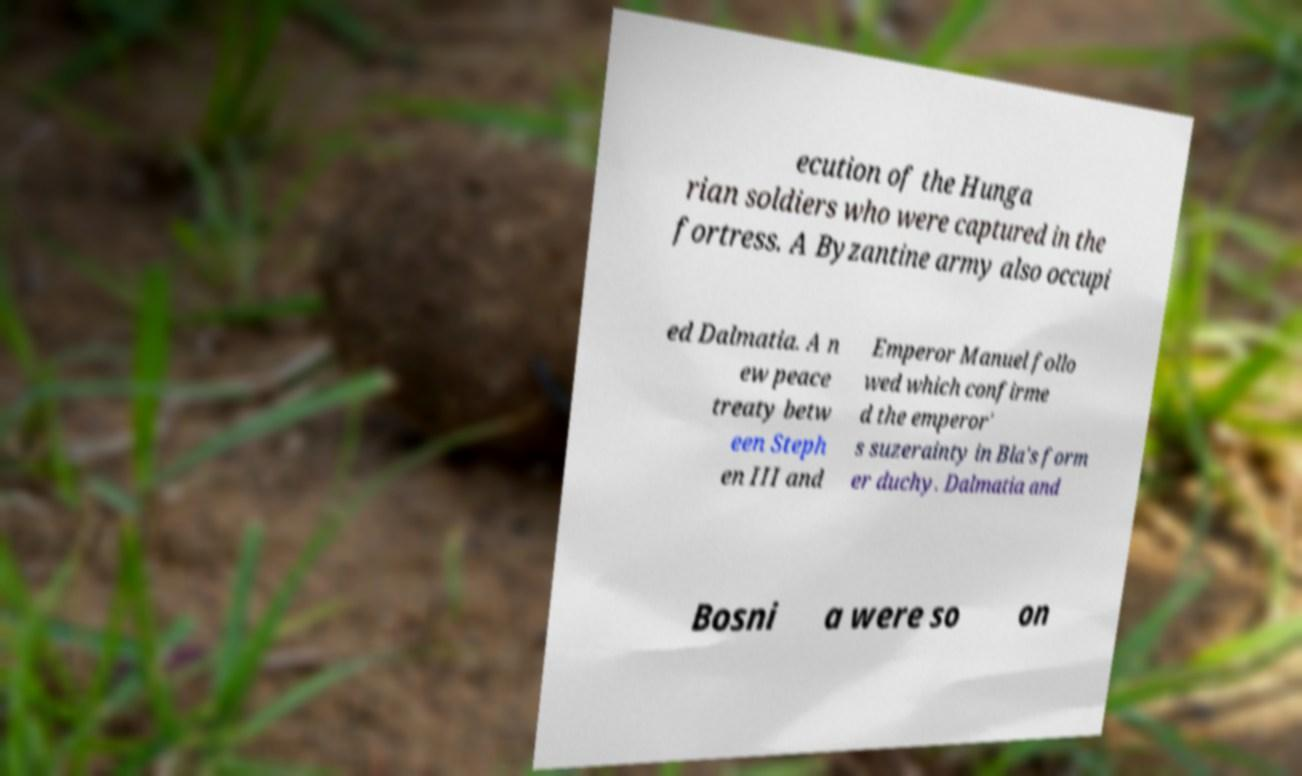What messages or text are displayed in this image? I need them in a readable, typed format. ecution of the Hunga rian soldiers who were captured in the fortress. A Byzantine army also occupi ed Dalmatia. A n ew peace treaty betw een Steph en III and Emperor Manuel follo wed which confirme d the emperor' s suzerainty in Bla's form er duchy. Dalmatia and Bosni a were so on 